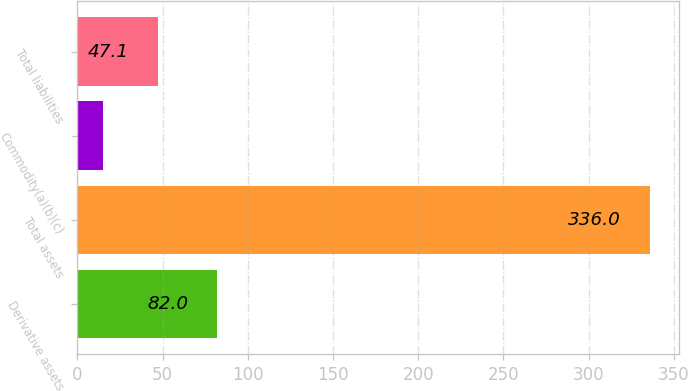<chart> <loc_0><loc_0><loc_500><loc_500><bar_chart><fcel>Derivative assets<fcel>Total assets<fcel>Commodity(a)(b)(c)<fcel>Total liabilities<nl><fcel>82<fcel>336<fcel>15<fcel>47.1<nl></chart> 